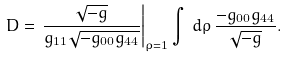<formula> <loc_0><loc_0><loc_500><loc_500>D = \left . \frac { \sqrt { - g } } { g _ { 1 1 } \sqrt { - g _ { 0 0 } g _ { 4 4 } } } \right | _ { \rho = 1 } \int \, d \rho \, \frac { - g _ { 0 0 } g _ { 4 4 } } { \sqrt { - g } } .</formula> 